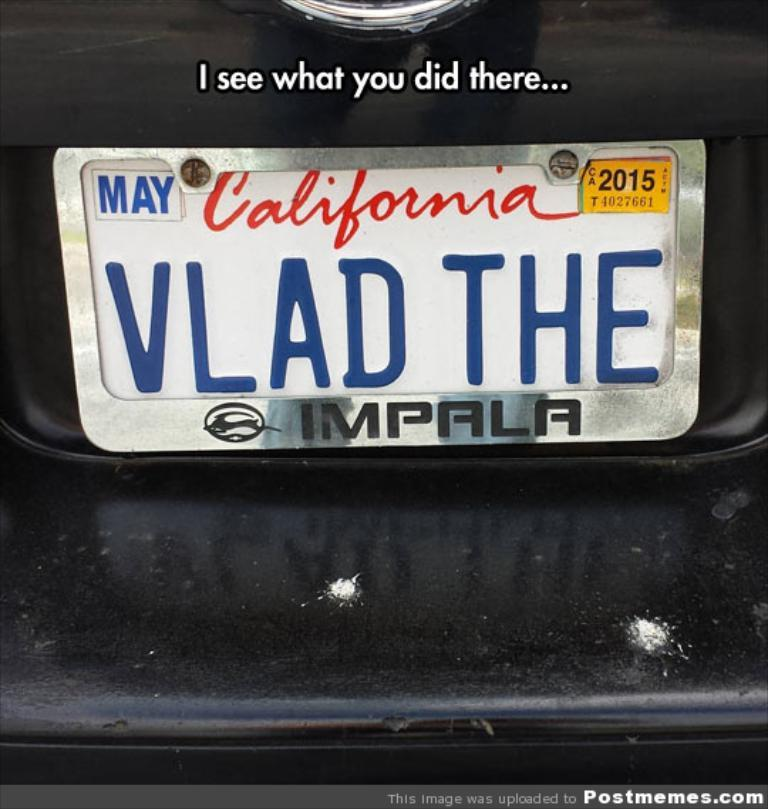<image>
Present a compact description of the photo's key features. A meme that shows a California tag saying VLAD THE with a tag frame that says Impala. 